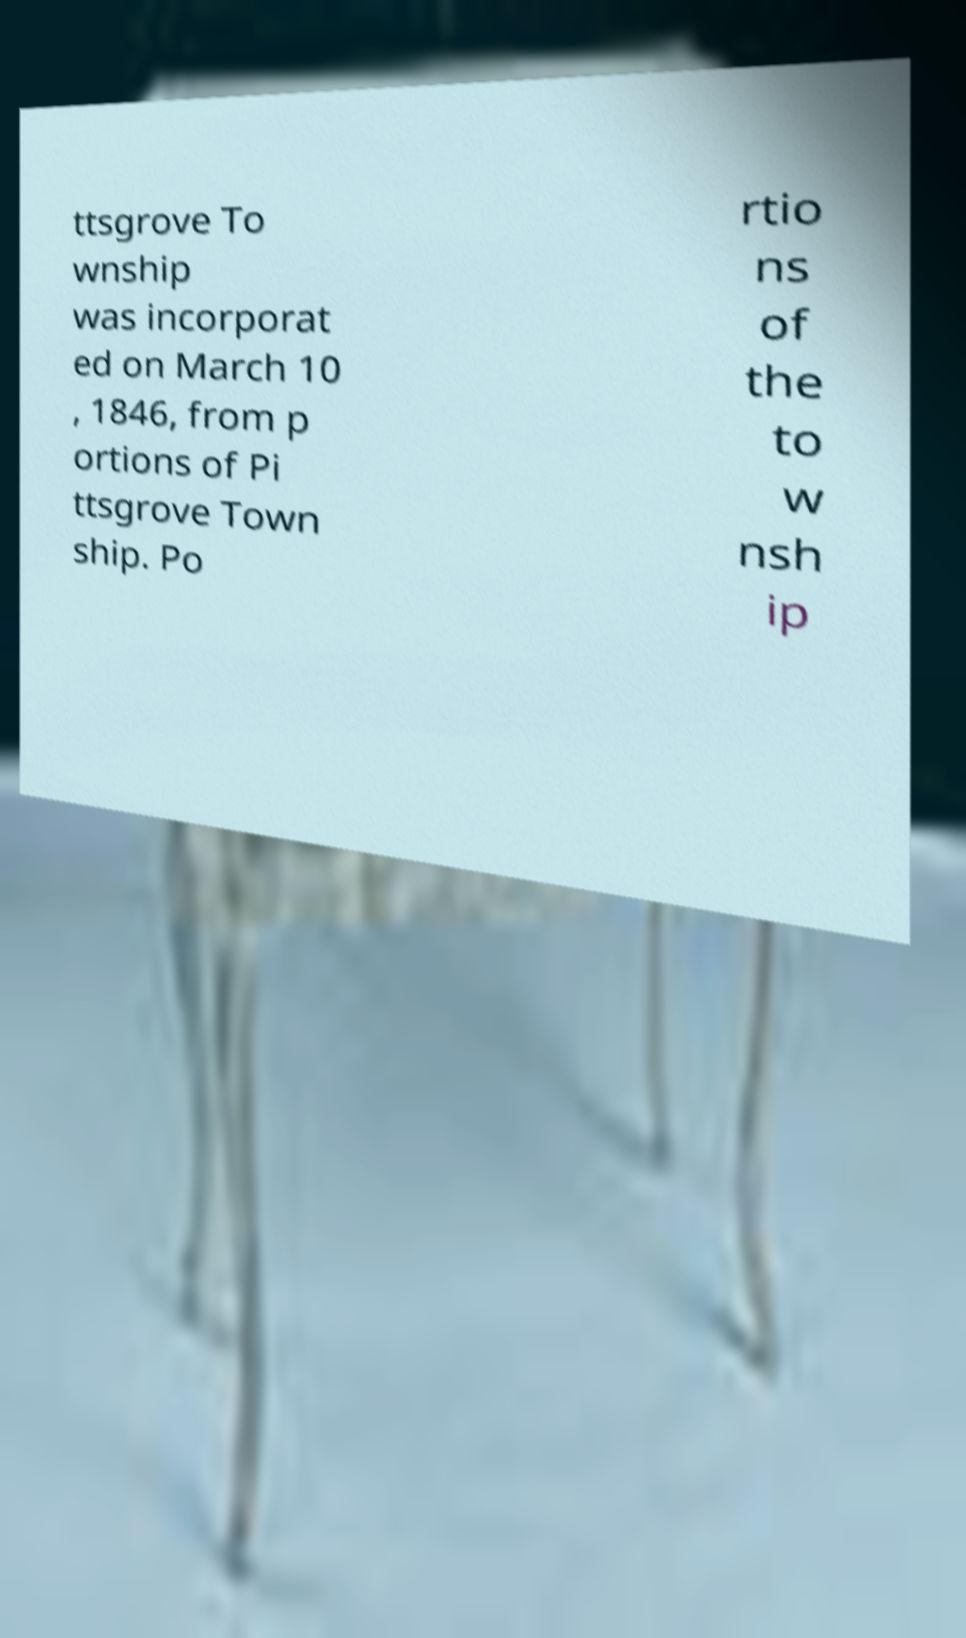There's text embedded in this image that I need extracted. Can you transcribe it verbatim? ttsgrove To wnship was incorporat ed on March 10 , 1846, from p ortions of Pi ttsgrove Town ship. Po rtio ns of the to w nsh ip 